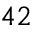<formula> <loc_0><loc_0><loc_500><loc_500>4 2</formula> 